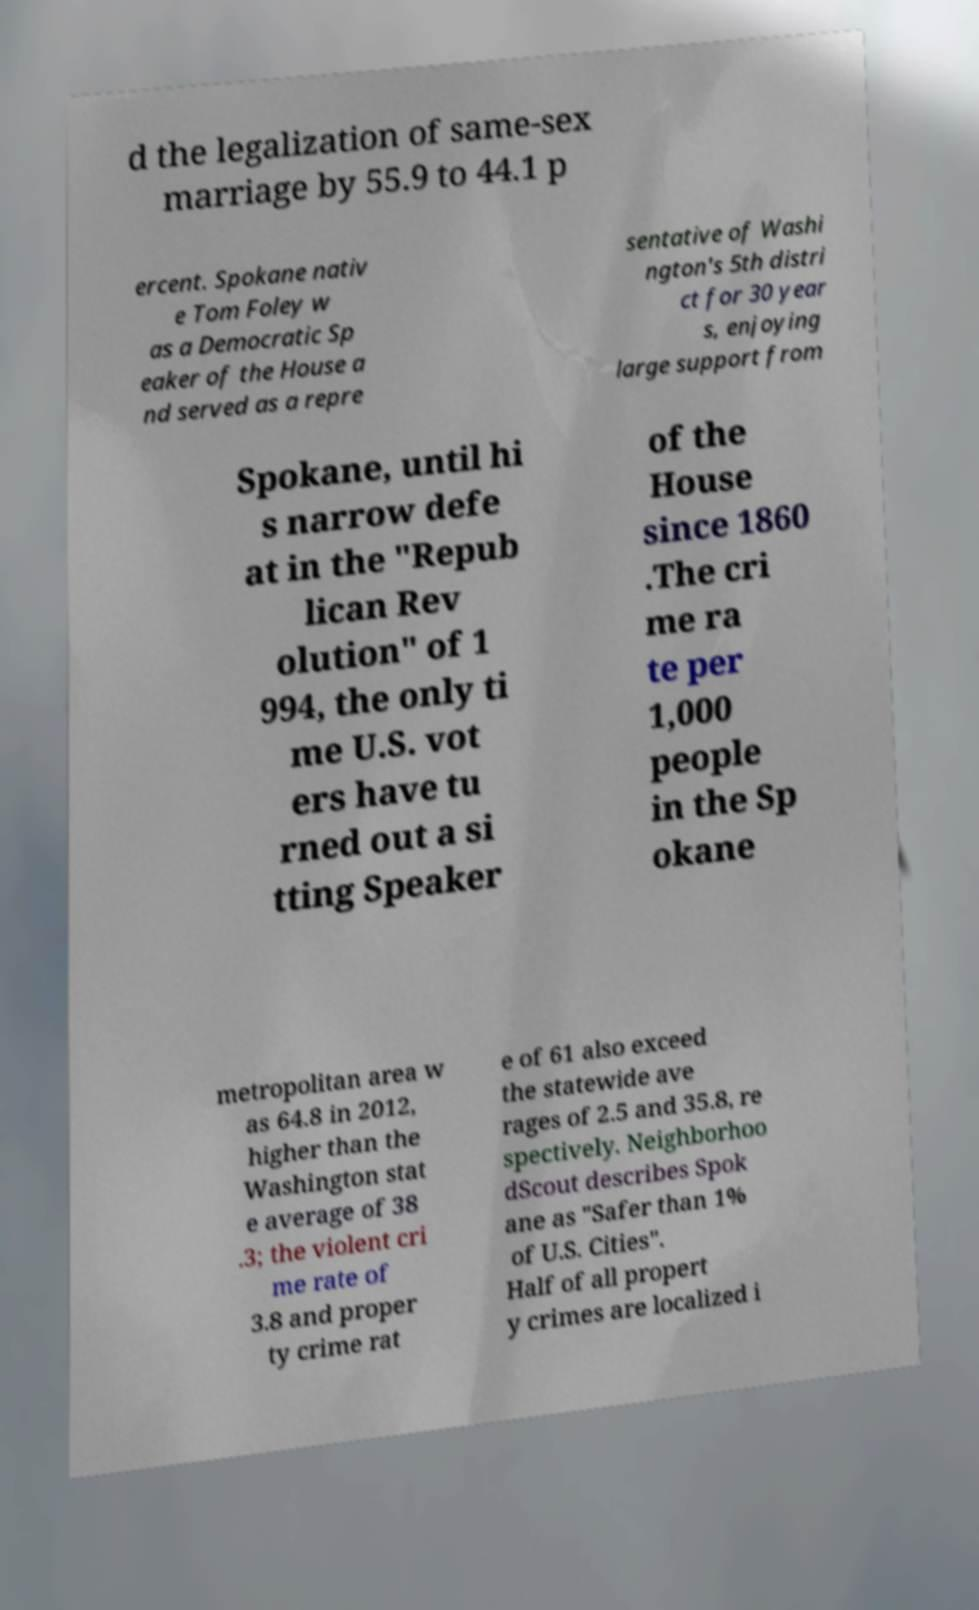Can you read and provide the text displayed in the image?This photo seems to have some interesting text. Can you extract and type it out for me? d the legalization of same-sex marriage by 55.9 to 44.1 p ercent. Spokane nativ e Tom Foley w as a Democratic Sp eaker of the House a nd served as a repre sentative of Washi ngton's 5th distri ct for 30 year s, enjoying large support from Spokane, until hi s narrow defe at in the "Repub lican Rev olution" of 1 994, the only ti me U.S. vot ers have tu rned out a si tting Speaker of the House since 1860 .The cri me ra te per 1,000 people in the Sp okane metropolitan area w as 64.8 in 2012, higher than the Washington stat e average of 38 .3; the violent cri me rate of 3.8 and proper ty crime rat e of 61 also exceed the statewide ave rages of 2.5 and 35.8, re spectively. Neighborhoo dScout describes Spok ane as "Safer than 1% of U.S. Cities". Half of all propert y crimes are localized i 